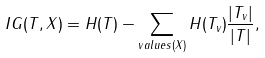<formula> <loc_0><loc_0><loc_500><loc_500>I G ( T , X ) = H ( T ) - \sum _ { v a l u e s ( X ) } H ( T _ { v } ) \frac { | T _ { v } | } { | T | } ,</formula> 